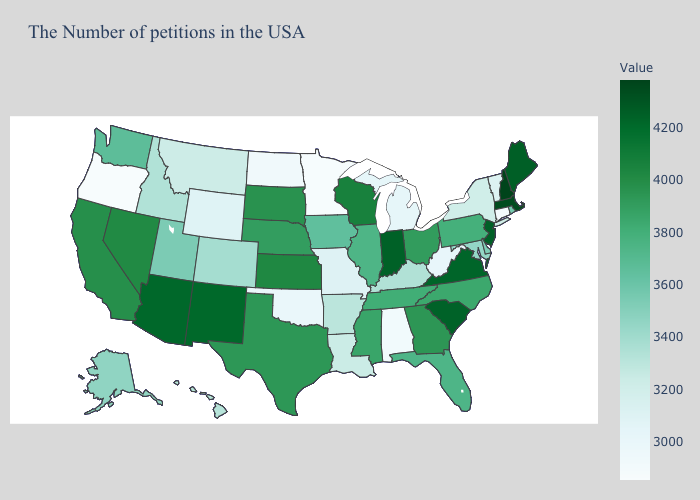Which states have the lowest value in the USA?
Give a very brief answer. Oregon. Which states have the lowest value in the Northeast?
Keep it brief. Connecticut. Among the states that border Colorado , does Kansas have the lowest value?
Write a very short answer. No. Does Iowa have the lowest value in the USA?
Answer briefly. No. Among the states that border Missouri , which have the highest value?
Give a very brief answer. Kansas. Among the states that border Idaho , does Nevada have the highest value?
Keep it brief. Yes. Which states have the highest value in the USA?
Be succinct. New Hampshire. Is the legend a continuous bar?
Be succinct. Yes. Does Maryland have the lowest value in the USA?
Be succinct. No. Does Arizona have the highest value in the West?
Give a very brief answer. Yes. Is the legend a continuous bar?
Give a very brief answer. Yes. 